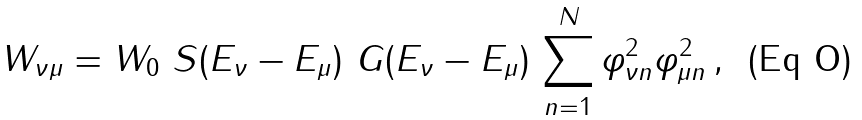<formula> <loc_0><loc_0><loc_500><loc_500>W _ { \nu \mu } = W _ { 0 } \ S ( E _ { \nu } - E _ { \mu } ) \ G ( E _ { \nu } - E _ { \mu } ) \, \sum _ { n = 1 } ^ { N } \varphi _ { \nu n } ^ { 2 } \varphi _ { \mu n } ^ { 2 } \, ,</formula> 